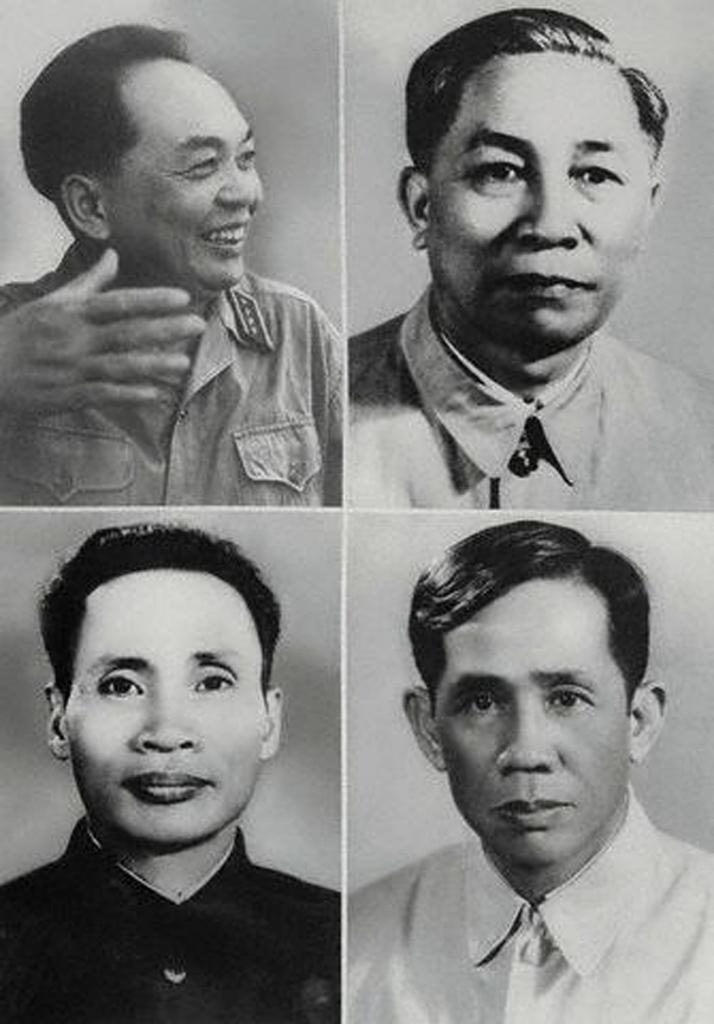What type of picture is in the image? There is a black and white picture in the image. How many people are in the picture? The picture contains four different people. Reasoning: Let' Let's think step by step in order to produce the conversation. We start by identifying the main subject in the image, which is the black and white picture. Then, we expand the conversation to include the number of people in the picture, which is four. Each question is designed to elicit a specific detail about the image that is known from the provided facts. Absurd Question/Answer: What type of fish can be seen swimming in the oatmeal in the image? There is no fish or oatmeal present in the image; it only contains a black and white picture with four people. What type of fish can be seen swimming in the oatmeal in the image? There is no fish or oatmeal present in the image; it only contains a black and white picture with four people. 